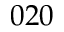<formula> <loc_0><loc_0><loc_500><loc_500>0 2 0</formula> 